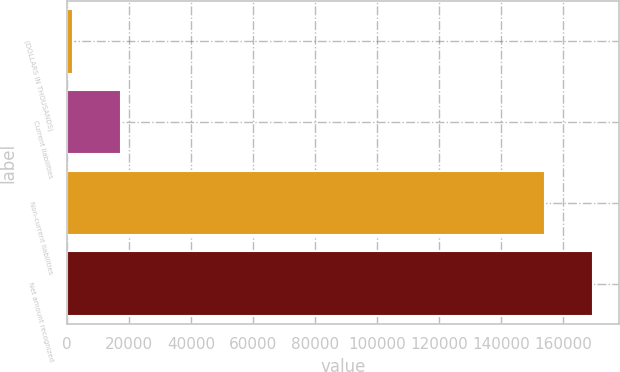Convert chart to OTSL. <chart><loc_0><loc_0><loc_500><loc_500><bar_chart><fcel>(DOLLARS IN THOUSANDS)<fcel>Current liabilities<fcel>Non-current liabilities<fcel>Net amount recognized<nl><fcel>2008<fcel>17482.3<fcel>154013<fcel>169487<nl></chart> 